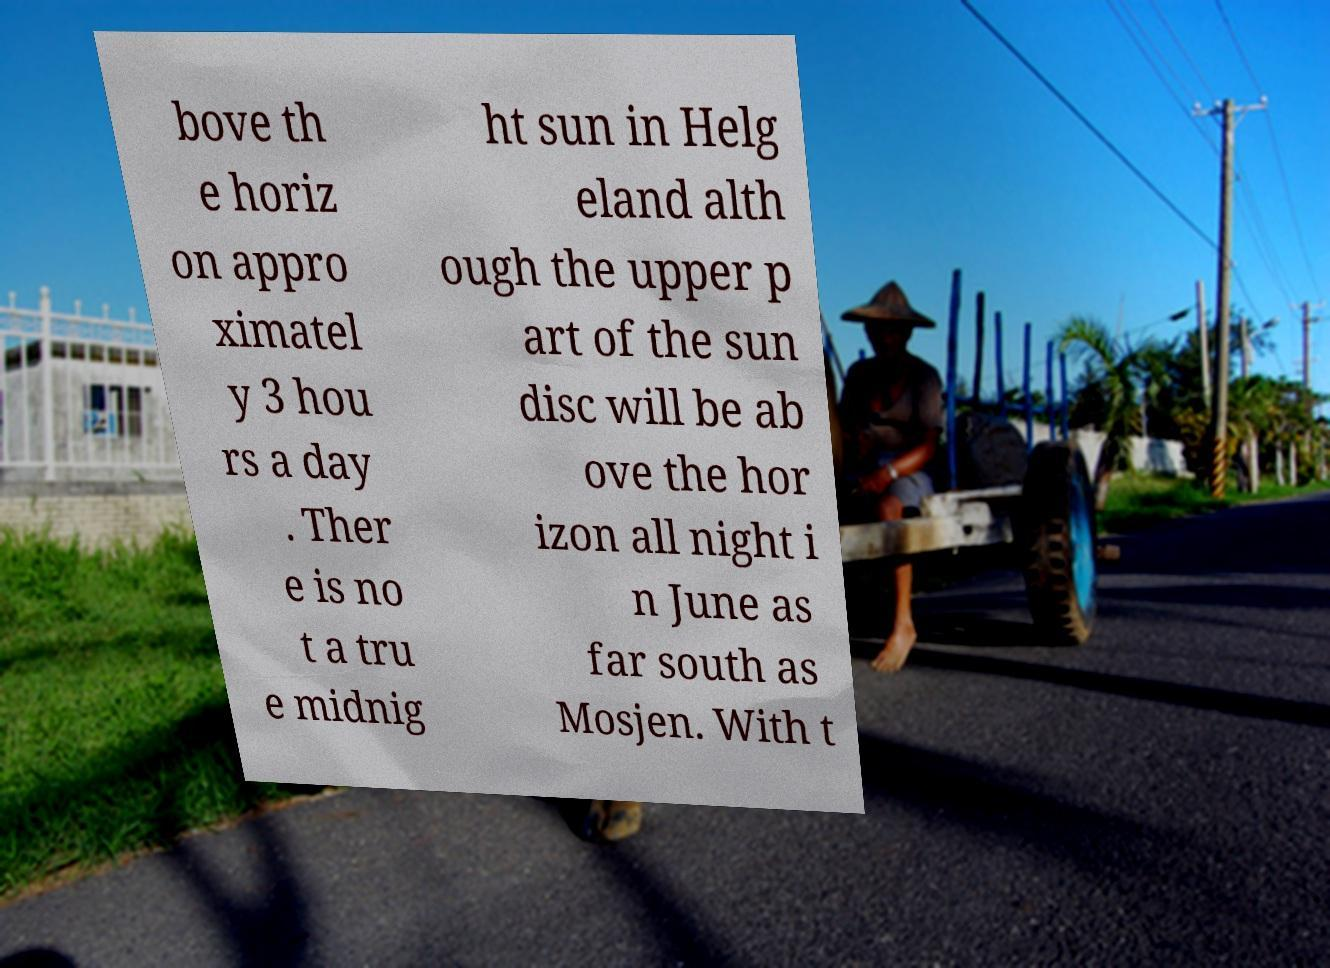Could you assist in decoding the text presented in this image and type it out clearly? bove th e horiz on appro ximatel y 3 hou rs a day . Ther e is no t a tru e midnig ht sun in Helg eland alth ough the upper p art of the sun disc will be ab ove the hor izon all night i n June as far south as Mosjen. With t 